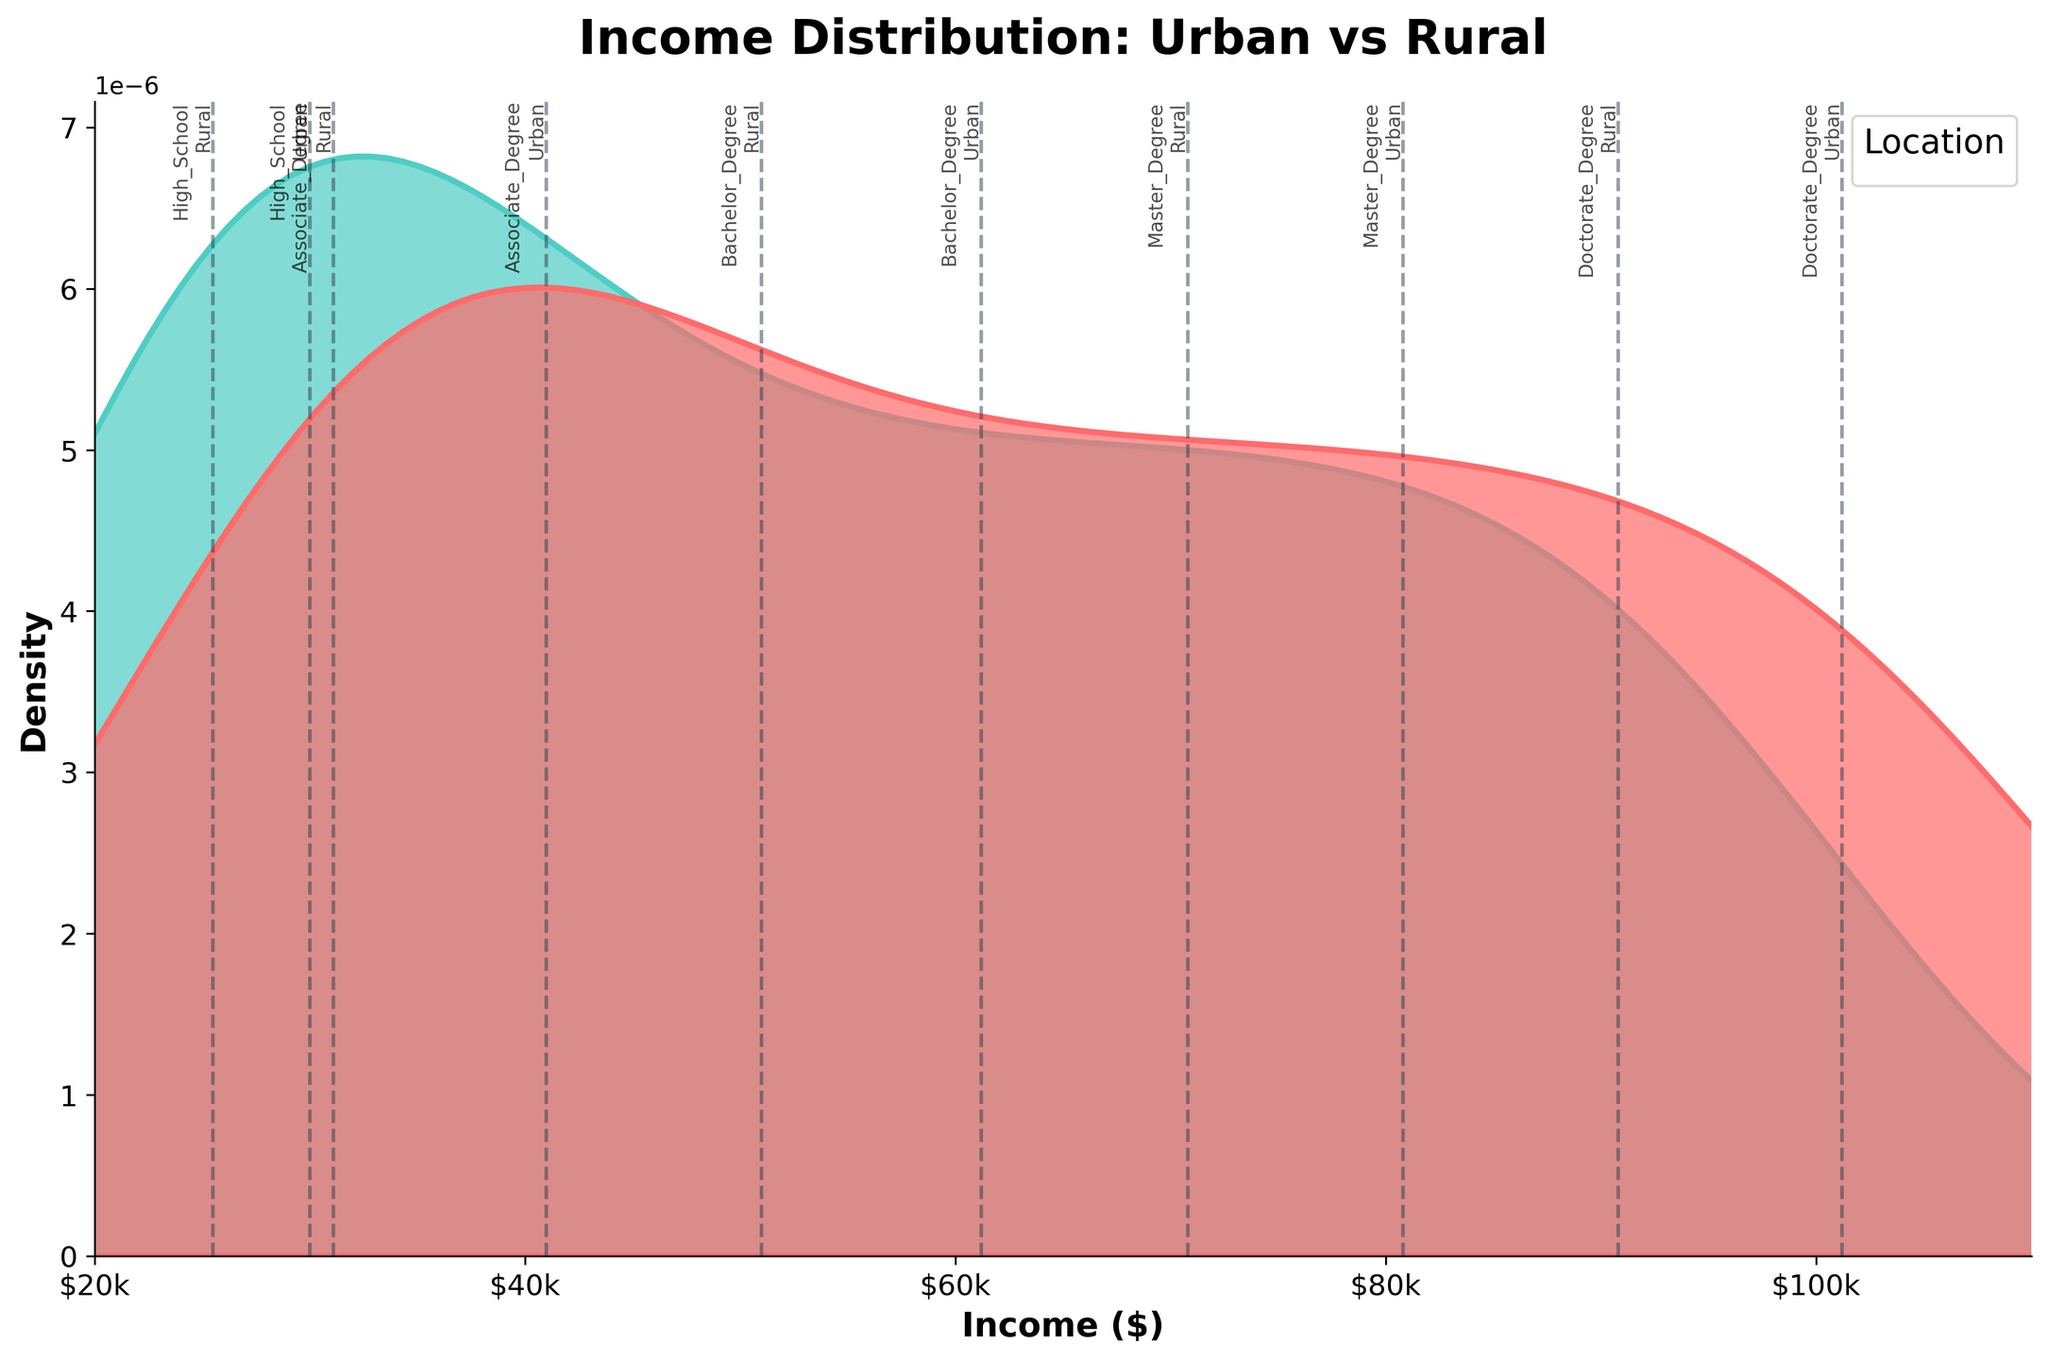What is the title of the figure? The title of the figure can be found at the top, which summarizes the content of the plot. It is "Income Distribution: Urban vs Rural".
Answer: Income Distribution: Urban vs Rural What are the labels for the x-axis and the y-axis? The labels for the axes indicate what variables are being measured. The x-axis is labeled 'Income ($)' and the y-axis is labeled 'Density'.
Answer: Income ($) and Density Which color represents urban areas? In density plots, the color palette is used to distinguish different groups. The color representing 'Urban' is red.
Answer: Red What is the peak density value for rural areas? The peak density can be observed by looking at the highest point on the density curve for rural areas. For rural areas, the peak density value is around 40k of income.
Answer: Around $40k How do the incomes for individuals with a Bachelor's degree compare between urban and rural areas? By examining the position and shape of the density curves for Bachelor's degree holders, we can see that the average income for Bachelor's degree holders in urban areas is higher than in rural areas, as the urban curve peaks at around $60k and the rural at around $50k.
Answer: Urban > Rural Where do the average incomes for Master's degree holders in urban and rural areas lie on the plot? The vertical dashed lines and the corresponding annotations on the x-axis indicate the average incomes. The average incomes for Master's degree holders in urban areas are around $80k, and in rural areas, they are around $70k.
Answer: Urban: $80k, Rural: $70k What can you infer about the income distribution for individuals with Associate degrees in urban vs rural areas? By comparing the shapes and peaks of the density plots for Associate degree holders, it is evident that the urban area has a higher average income (around $40k) than rural areas (around $30k). Additionally, urban areas have a narrower distribution, suggesting more consistency in incomes.
Answer: Urban higher and narrower How do the income distributions differ between high school graduates in urban and rural areas? The density plots for high school graduates show that urban high school graduates have a higher average income (around $30k) compared to rural high school graduates (around $25k). The urban density plot is also somewhat narrower.
Answer: Urban higher and narrower Which educational level shows the smallest income gap between urban and rural areas? By observing the vertical dashed lines representing average incomes, we see that the income gap is smallest for Doctorate degree holders, with urban averages around $100k and rural around $90k.
Answer: Doctorate Degree What is the trend in income as educational attainment increases for both urban and rural areas? By following the location of the vertical dashed lines from left to right, we can see that income consistently increases with higher educational attainment for both urban and rural areas.
Answer: Income increases with education for both areas 